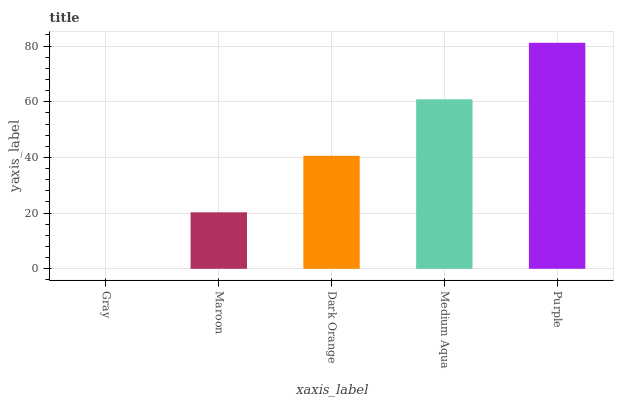Is Gray the minimum?
Answer yes or no. Yes. Is Purple the maximum?
Answer yes or no. Yes. Is Maroon the minimum?
Answer yes or no. No. Is Maroon the maximum?
Answer yes or no. No. Is Maroon greater than Gray?
Answer yes or no. Yes. Is Gray less than Maroon?
Answer yes or no. Yes. Is Gray greater than Maroon?
Answer yes or no. No. Is Maroon less than Gray?
Answer yes or no. No. Is Dark Orange the high median?
Answer yes or no. Yes. Is Dark Orange the low median?
Answer yes or no. Yes. Is Purple the high median?
Answer yes or no. No. Is Maroon the low median?
Answer yes or no. No. 